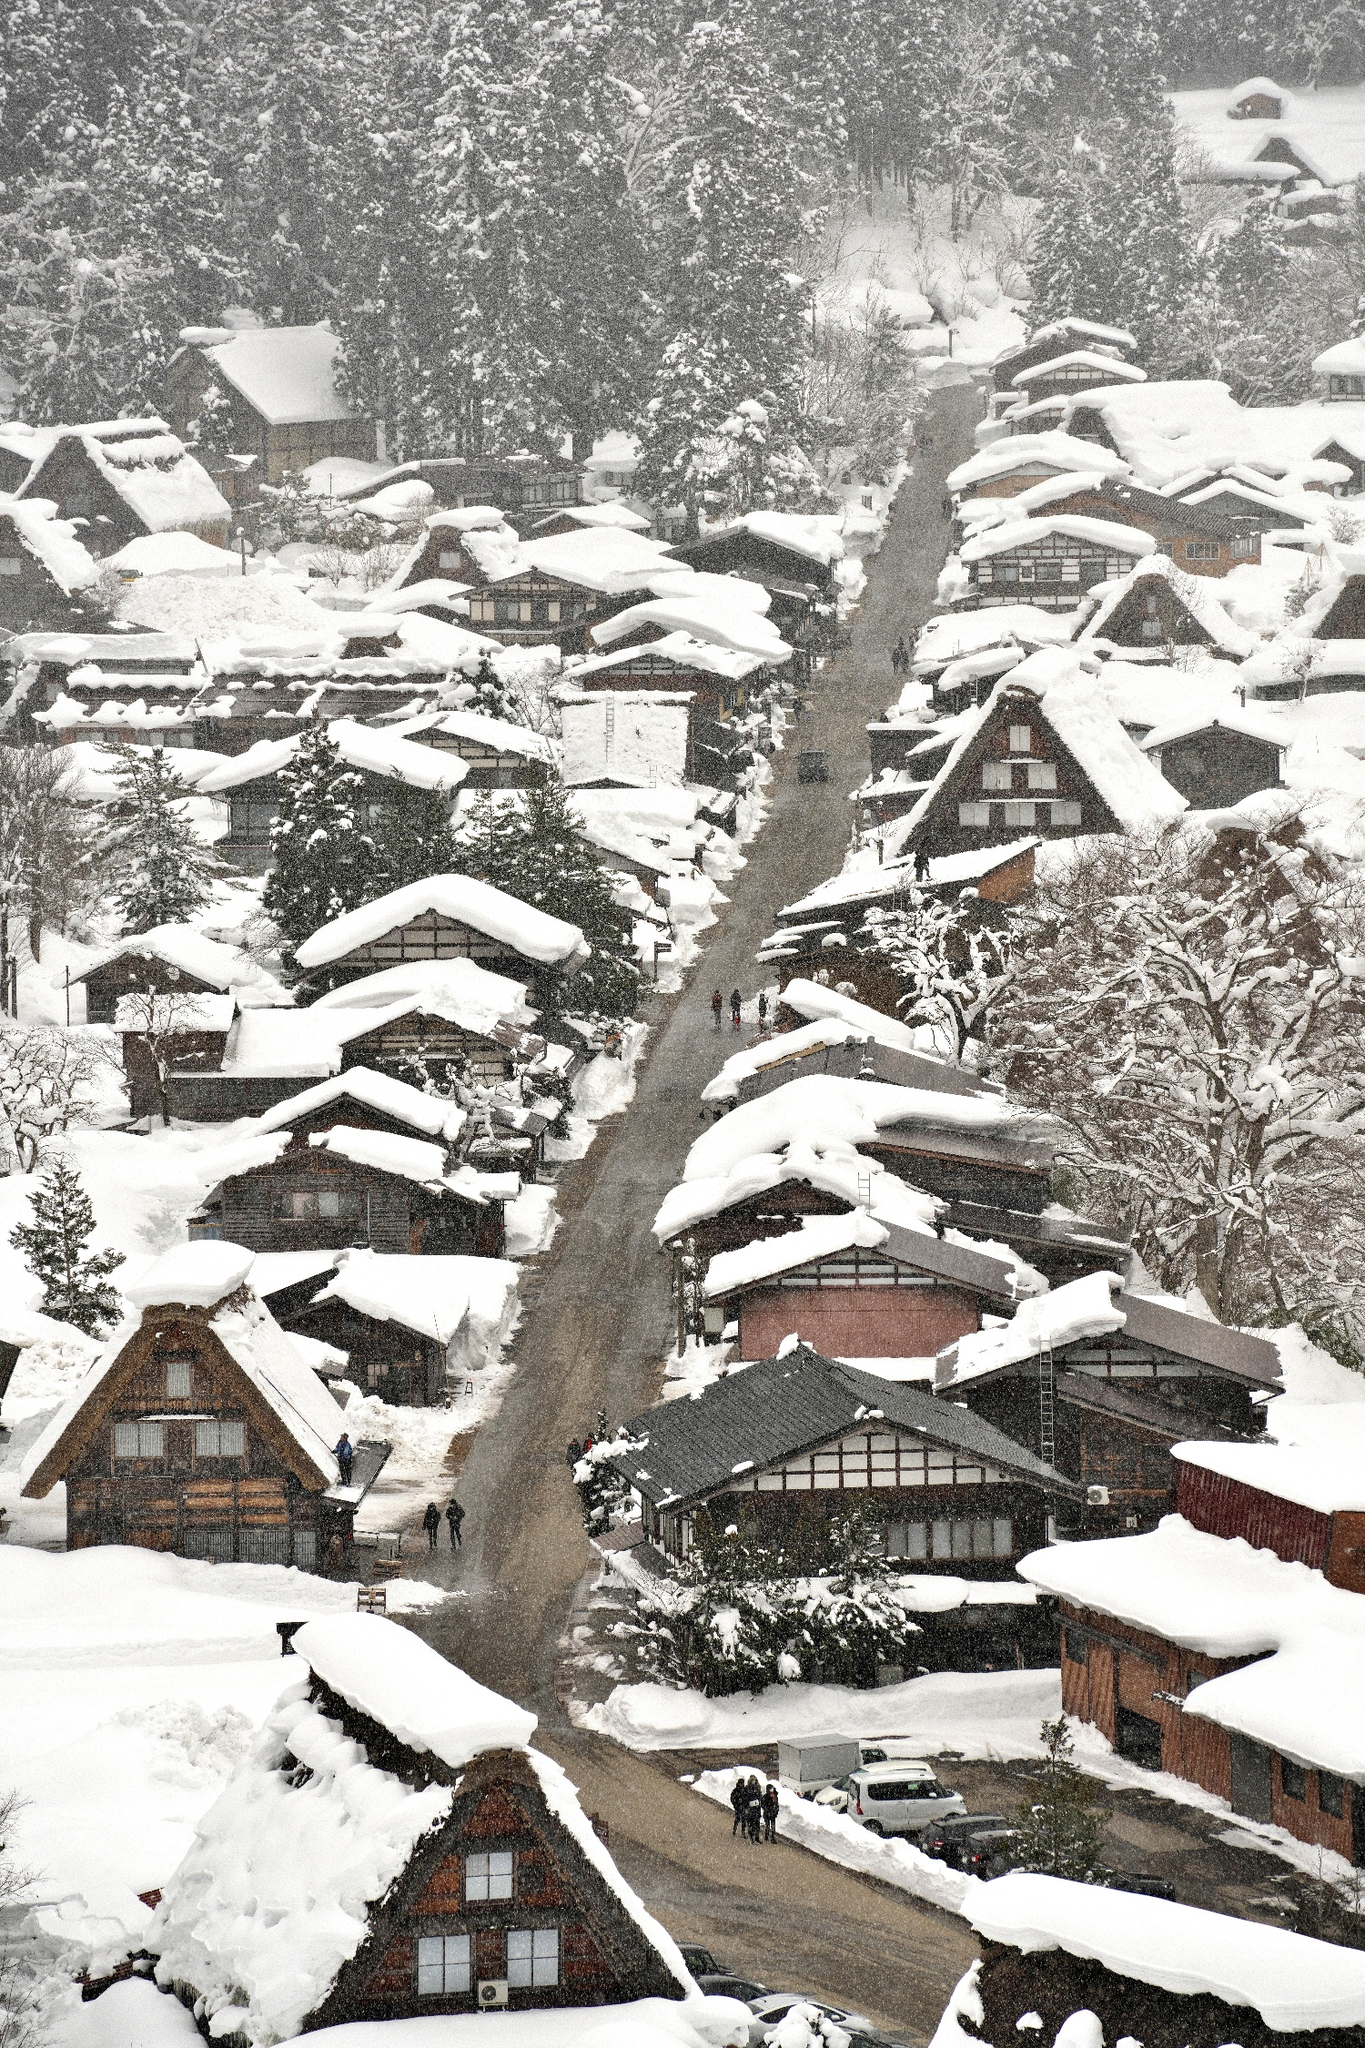How is daily life likely to be in this snowy environment? Daily life in this snowy environment of Shirakawa-go involves rigorous winter preparation and maintenance, including snow removal from walkways and roofs. The residents likely engage in communal efforts to keep the village accessible. Winters can isolate the village, making the community more reliant on each other. Despite these challenges, the serene and picturesque landscape offers a unique living experience deeply connected with nature and traditional practices. 